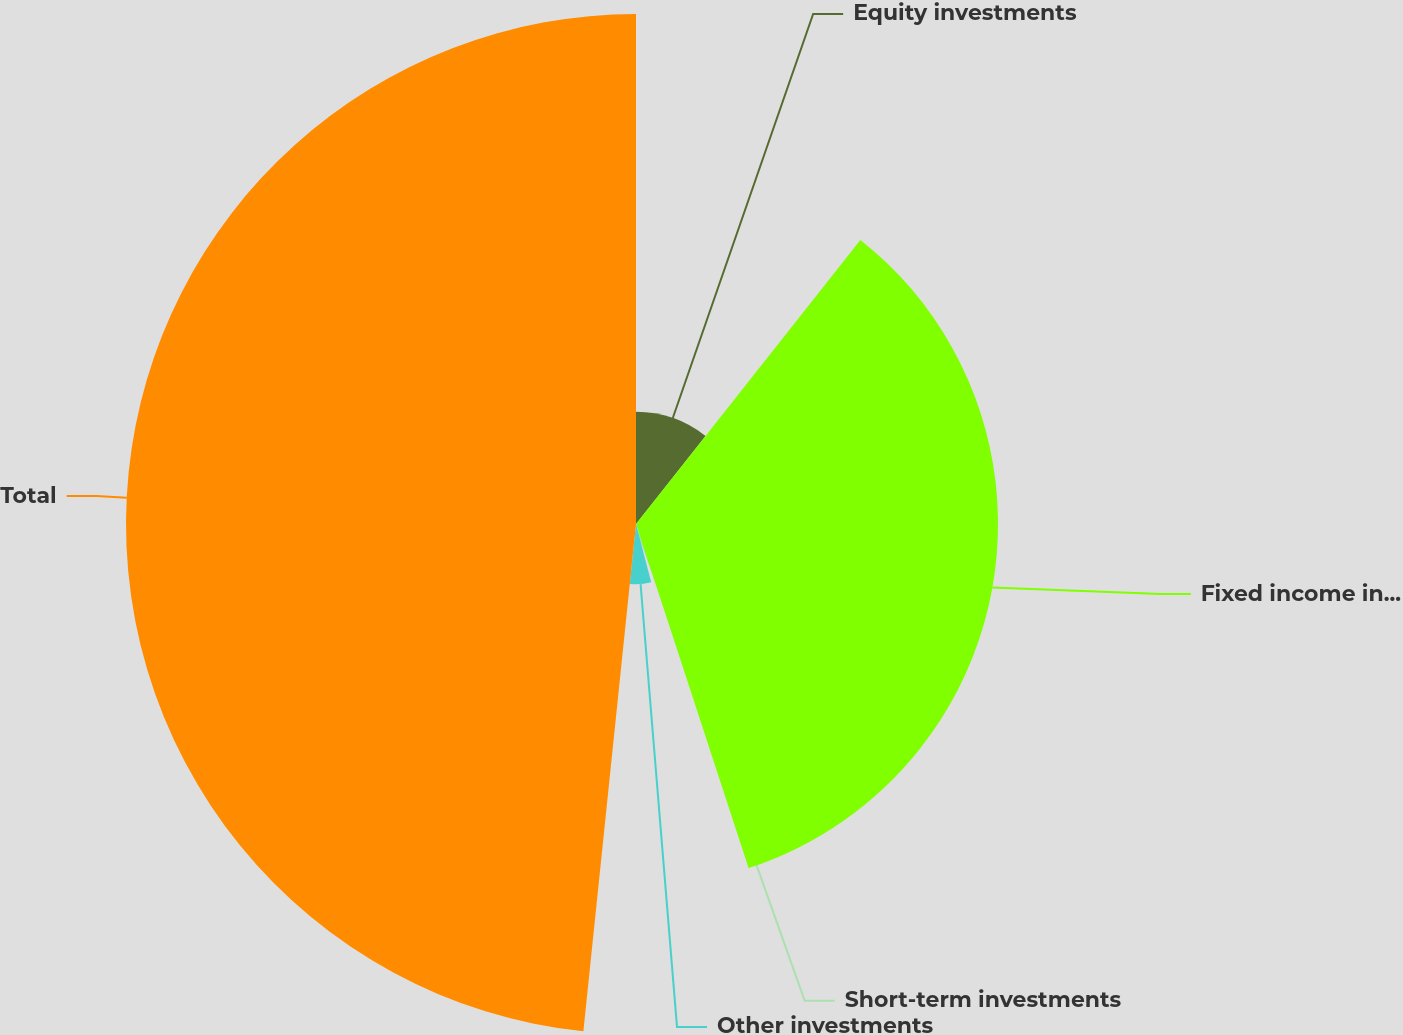Convert chart. <chart><loc_0><loc_0><loc_500><loc_500><pie_chart><fcel>Equity investments<fcel>Fixed income investments<fcel>Short-term investments<fcel>Other investments<fcel>Total<nl><fcel>10.64%<fcel>34.33%<fcel>0.97%<fcel>5.71%<fcel>48.36%<nl></chart> 